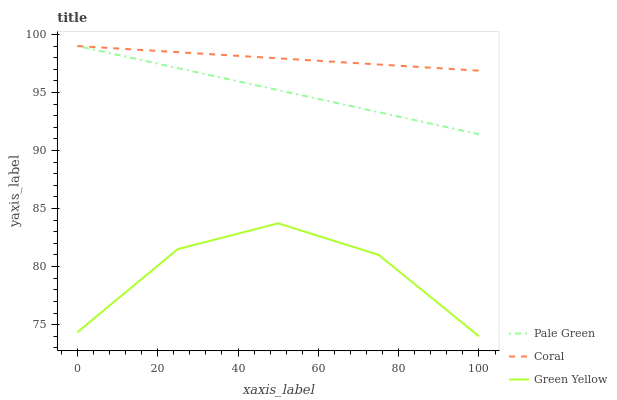Does Green Yellow have the minimum area under the curve?
Answer yes or no. Yes. Does Coral have the maximum area under the curve?
Answer yes or no. Yes. Does Pale Green have the minimum area under the curve?
Answer yes or no. No. Does Pale Green have the maximum area under the curve?
Answer yes or no. No. Is Pale Green the smoothest?
Answer yes or no. Yes. Is Green Yellow the roughest?
Answer yes or no. Yes. Is Green Yellow the smoothest?
Answer yes or no. No. Is Pale Green the roughest?
Answer yes or no. No. Does Green Yellow have the lowest value?
Answer yes or no. Yes. Does Pale Green have the lowest value?
Answer yes or no. No. Does Pale Green have the highest value?
Answer yes or no. Yes. Does Green Yellow have the highest value?
Answer yes or no. No. Is Green Yellow less than Pale Green?
Answer yes or no. Yes. Is Coral greater than Green Yellow?
Answer yes or no. Yes. Does Pale Green intersect Coral?
Answer yes or no. Yes. Is Pale Green less than Coral?
Answer yes or no. No. Is Pale Green greater than Coral?
Answer yes or no. No. Does Green Yellow intersect Pale Green?
Answer yes or no. No. 